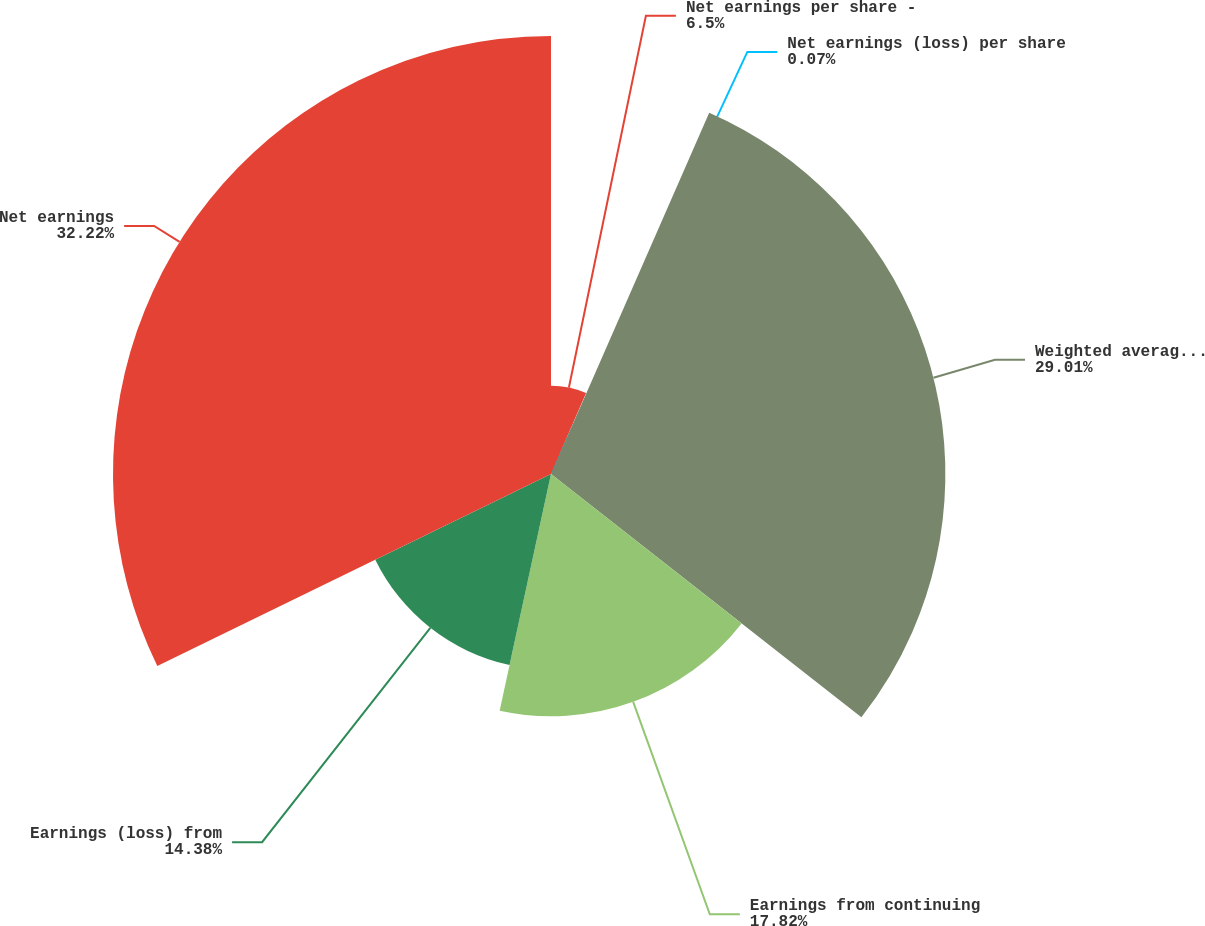Convert chart. <chart><loc_0><loc_0><loc_500><loc_500><pie_chart><fcel>Net earnings per share -<fcel>Net earnings (loss) per share<fcel>Weighted average shares -<fcel>Earnings from continuing<fcel>Earnings (loss) from<fcel>Net earnings<nl><fcel>6.5%<fcel>0.07%<fcel>29.01%<fcel>17.82%<fcel>14.38%<fcel>32.22%<nl></chart> 